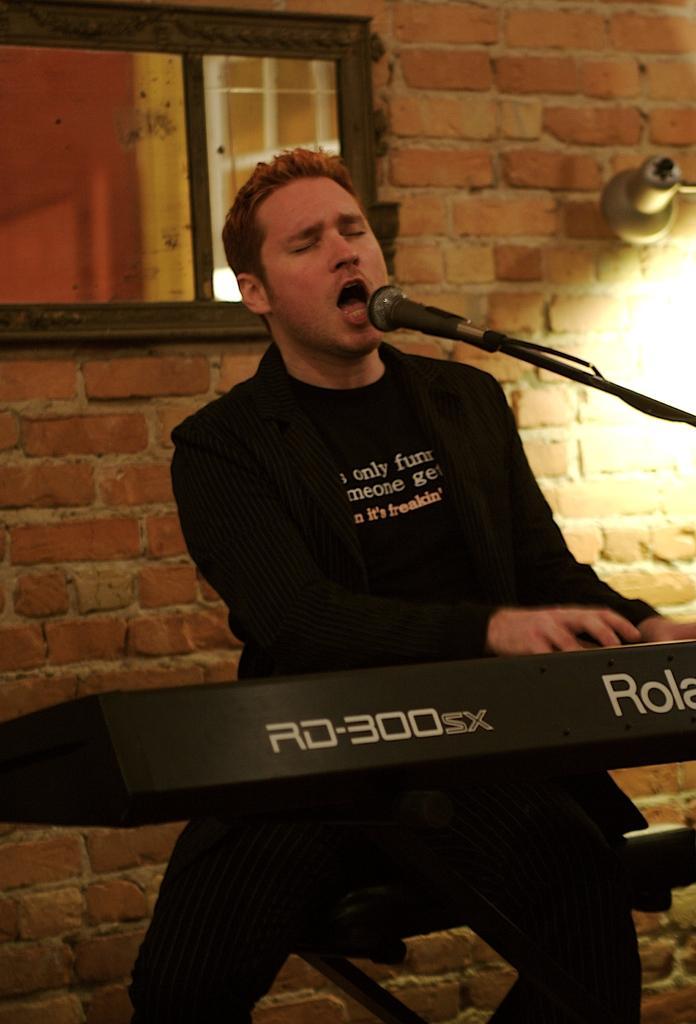Please provide a concise description of this image. In this image there is a person in the middle, in front of him there is the mike, musical instrument, behind him there is a window, wall and light on the right side. 